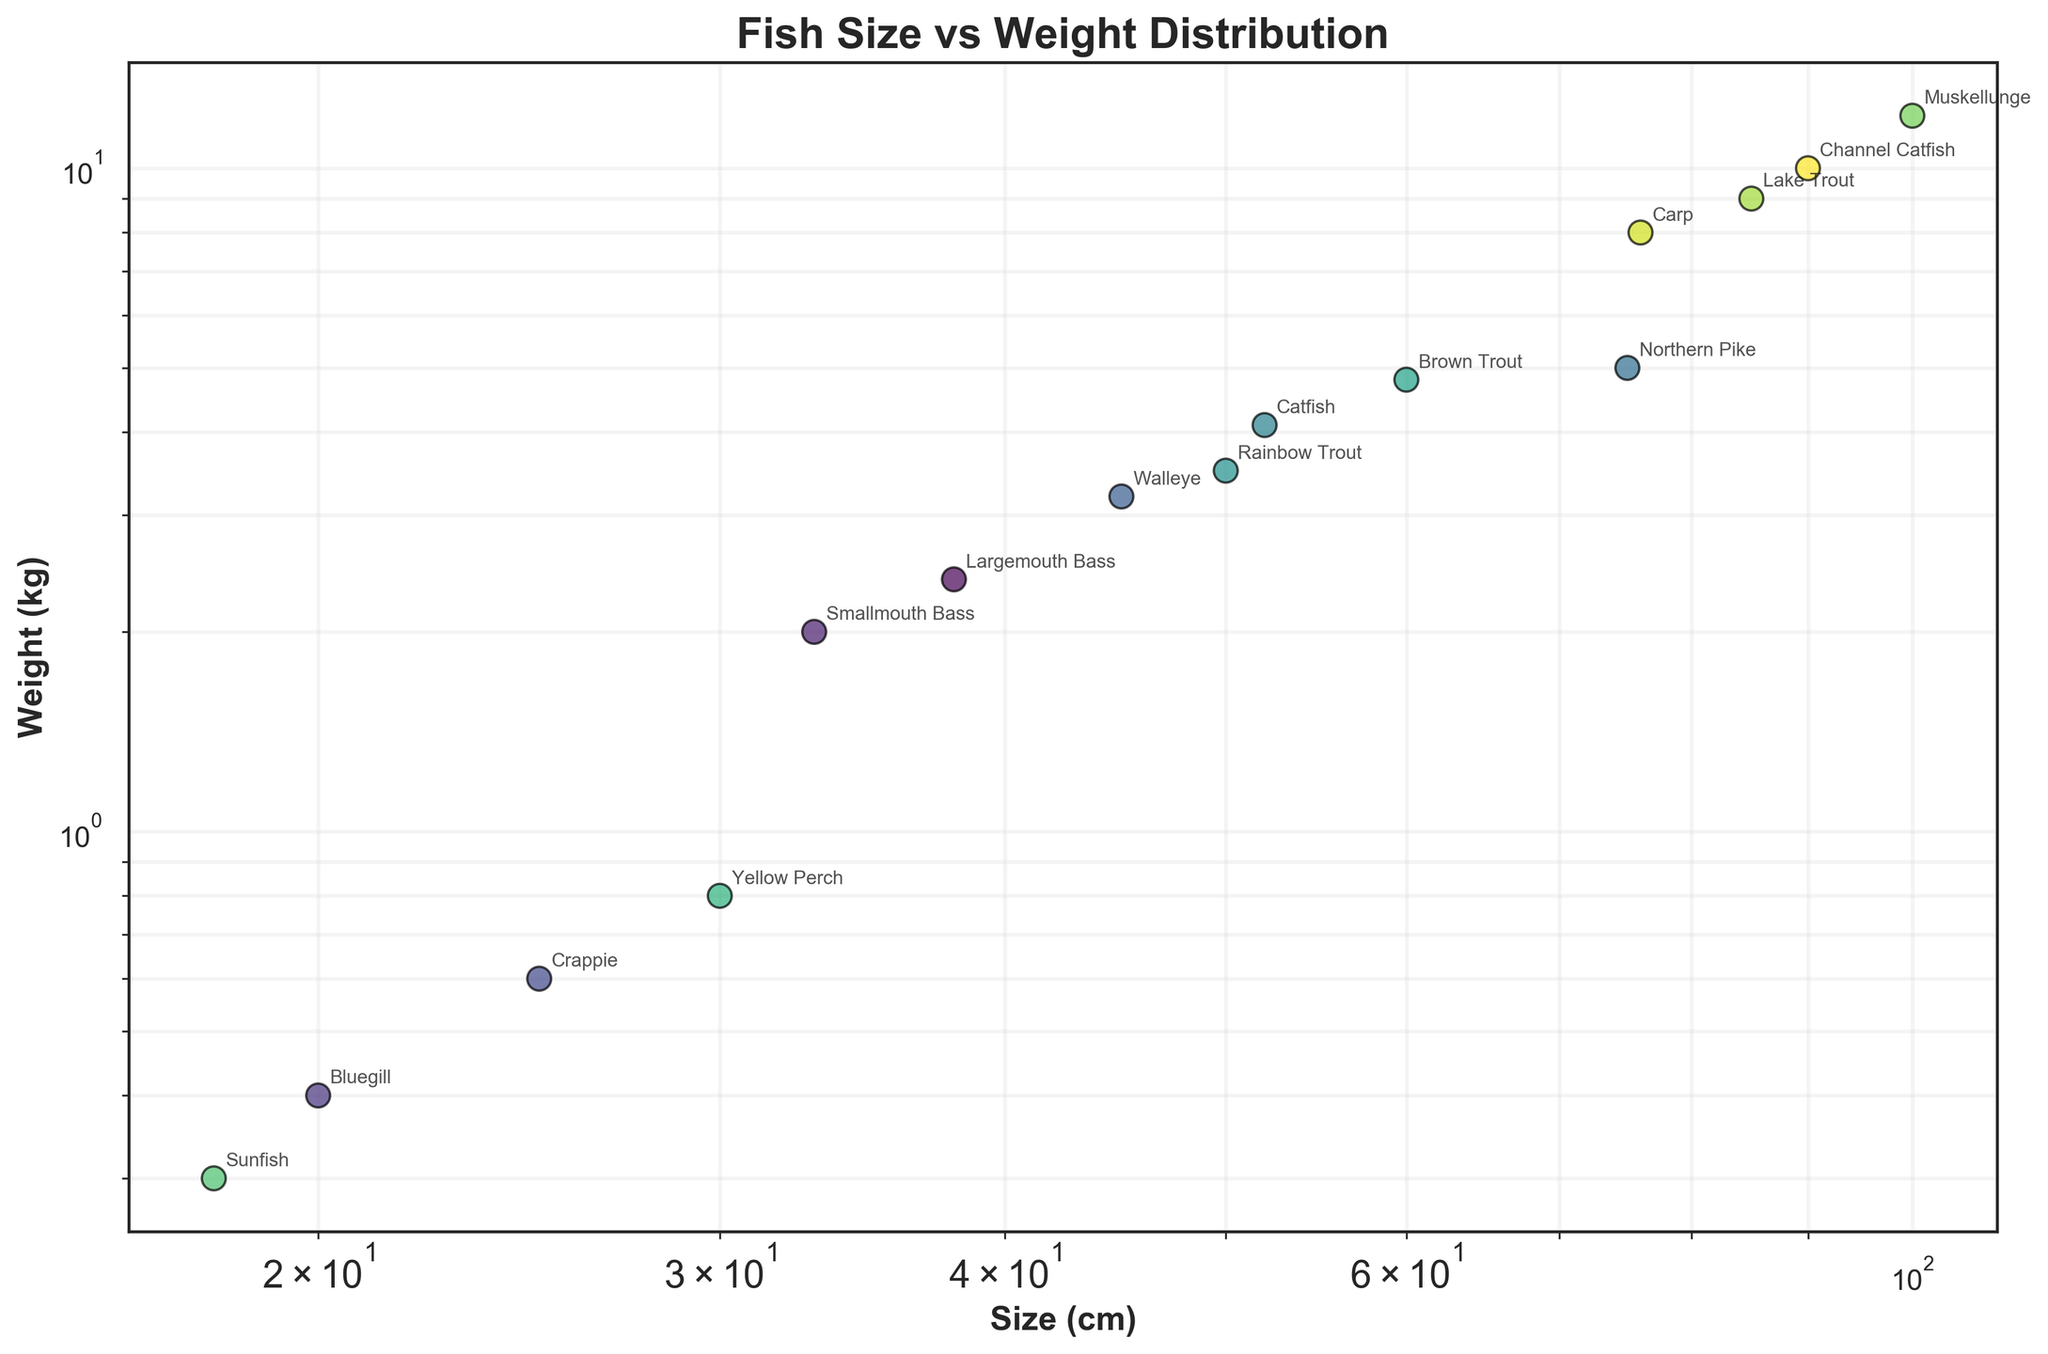How many fish species are listed in the plot? By counting all the different labeled points on the scatter plot, we can see that there are 15 different fish species annotated.
Answer: 15 Which fish species has the largest size on the plot? By inspecting the x-axis (Size) and looking for the furthest point to the right, we find that the Muskellunge has the largest size, with an annotation clearly indicating 100 cm.
Answer: Muskellunge Which fish species has the smallest weight on the plot? By inspecting the y-axis (Weight) and looking for the lowest point, we find the Sunfish, which is annotated with a weight of 0.3 kg.
Answer: Sunfish What's the total weight of the three heaviest fish species? The three heaviest fish species are Muskellunge (12.0 kg), Channel Catfish (10.0 kg), and Lake Trout (9.0 kg). Adding these weights together gives 12.0 + 10.0 + 9.0 = 31.0 kg.
Answer: 31.0 kg Which fish species has a size between 50 cm and 60 cm and a weight greater than 4 kg? By examining the data points within the specified size range and weight criterion, we find that the Brown Trout fits this description with a size of 60 cm and weight of 4.8 kg.
Answer: Brown Trout What is the average weight of fish species that have a size greater than 70 cm? The fish species with sizes greater than 70 cm are Northern Pike (75 cm, 5.0 kg), Carp (76 cm, 8.0 kg), Lake Trout (85 cm, 9.0 kg), Channel Catfish (90 cm, 10.0 kg), and Muskellunge (100 cm, 12.0 kg). Their weights are 5.0, 8.0, 9.0, 10.0, and 12.0 kg. To find the average: (5.0 + 8.0 + 9.0 + 10.0 + 12.0) / 5 = 44.0 / 5 = 8.8 kg.
Answer: 8.8 kg Which is heavier, a Northern Pike or a Catfish? From the plot, the Northern Pike has a weight of 5.0 kg, while the Catfish has a weight of 4.1 kg. Therefore, the Northern Pike is heavier than the Catfish.
Answer: Northern Pike What is the log-scaled representation's main advantage in this scatter plot? By using a log scale on both axes, the plot effectively displays a wide range of sizes and weights, allowing for better visualization of the data points that would otherwise be compressed in a linear scale due to their large variance.
Answer: Better visualization of wide data ranges Which fish species are closest in size but vary the most in weight? Upon examining the plot, Largemouth Bass (38 cm, 2.4 kg) and Smallmouth Bass (33 cm, 2.0 kg) are closest in size. The weight difference is minimal compared to this question's requirements. However, if we consider a slight size difference of 5 cm or more, Northern Pike (75 cm, 5.0 kg) and Carp (76 cm, 8.0 kg) are close in size but vary significantly in weight.
Answer: Northern Pike and Carp 